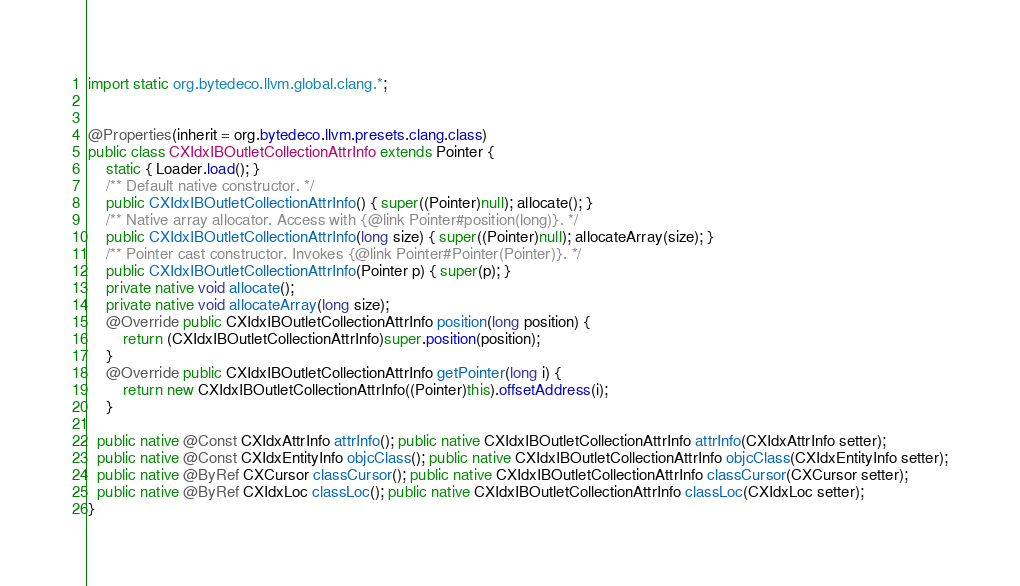Convert code to text. <code><loc_0><loc_0><loc_500><loc_500><_Java_>
import static org.bytedeco.llvm.global.clang.*;


@Properties(inherit = org.bytedeco.llvm.presets.clang.class)
public class CXIdxIBOutletCollectionAttrInfo extends Pointer {
    static { Loader.load(); }
    /** Default native constructor. */
    public CXIdxIBOutletCollectionAttrInfo() { super((Pointer)null); allocate(); }
    /** Native array allocator. Access with {@link Pointer#position(long)}. */
    public CXIdxIBOutletCollectionAttrInfo(long size) { super((Pointer)null); allocateArray(size); }
    /** Pointer cast constructor. Invokes {@link Pointer#Pointer(Pointer)}. */
    public CXIdxIBOutletCollectionAttrInfo(Pointer p) { super(p); }
    private native void allocate();
    private native void allocateArray(long size);
    @Override public CXIdxIBOutletCollectionAttrInfo position(long position) {
        return (CXIdxIBOutletCollectionAttrInfo)super.position(position);
    }
    @Override public CXIdxIBOutletCollectionAttrInfo getPointer(long i) {
        return new CXIdxIBOutletCollectionAttrInfo((Pointer)this).offsetAddress(i);
    }

  public native @Const CXIdxAttrInfo attrInfo(); public native CXIdxIBOutletCollectionAttrInfo attrInfo(CXIdxAttrInfo setter);
  public native @Const CXIdxEntityInfo objcClass(); public native CXIdxIBOutletCollectionAttrInfo objcClass(CXIdxEntityInfo setter);
  public native @ByRef CXCursor classCursor(); public native CXIdxIBOutletCollectionAttrInfo classCursor(CXCursor setter);
  public native @ByRef CXIdxLoc classLoc(); public native CXIdxIBOutletCollectionAttrInfo classLoc(CXIdxLoc setter);
}
</code> 